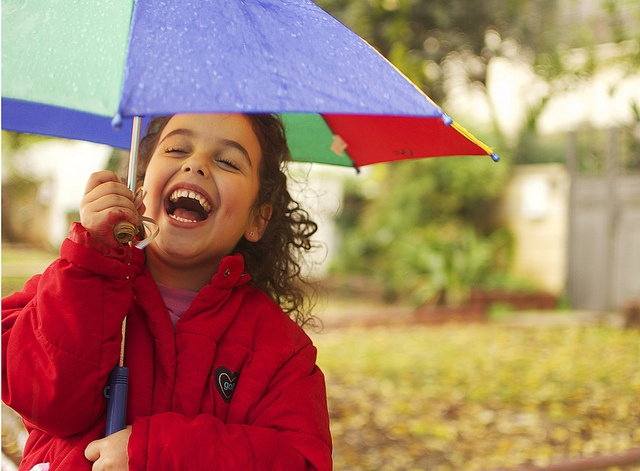Describe the objects in this image and their specific colors. I can see people in white, brown, maroon, and black tones and umbrella in white, lightblue, beige, and brown tones in this image. 